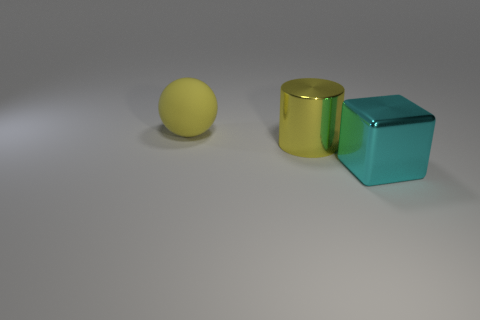Add 3 yellow metal cylinders. How many objects exist? 6 Add 2 large metallic cylinders. How many large metallic cylinders exist? 3 Subtract 0 green spheres. How many objects are left? 3 Subtract all cylinders. How many objects are left? 2 Subtract all balls. Subtract all large cyan objects. How many objects are left? 1 Add 1 metal cylinders. How many metal cylinders are left? 2 